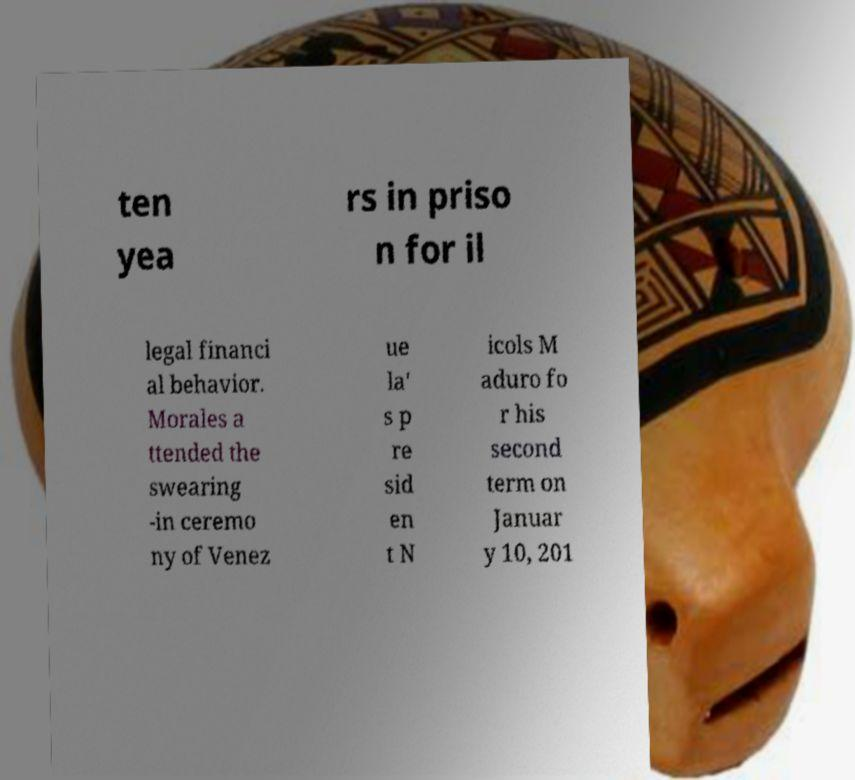Can you accurately transcribe the text from the provided image for me? ten yea rs in priso n for il legal financi al behavior. Morales a ttended the swearing -in ceremo ny of Venez ue la' s p re sid en t N icols M aduro fo r his second term on Januar y 10, 201 